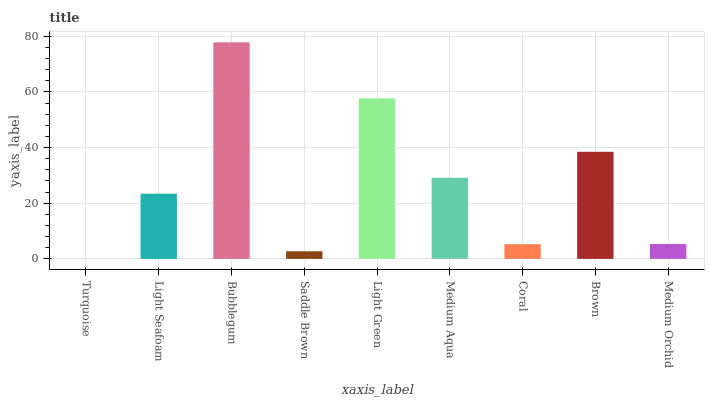Is Turquoise the minimum?
Answer yes or no. Yes. Is Bubblegum the maximum?
Answer yes or no. Yes. Is Light Seafoam the minimum?
Answer yes or no. No. Is Light Seafoam the maximum?
Answer yes or no. No. Is Light Seafoam greater than Turquoise?
Answer yes or no. Yes. Is Turquoise less than Light Seafoam?
Answer yes or no. Yes. Is Turquoise greater than Light Seafoam?
Answer yes or no. No. Is Light Seafoam less than Turquoise?
Answer yes or no. No. Is Light Seafoam the high median?
Answer yes or no. Yes. Is Light Seafoam the low median?
Answer yes or no. Yes. Is Saddle Brown the high median?
Answer yes or no. No. Is Medium Aqua the low median?
Answer yes or no. No. 